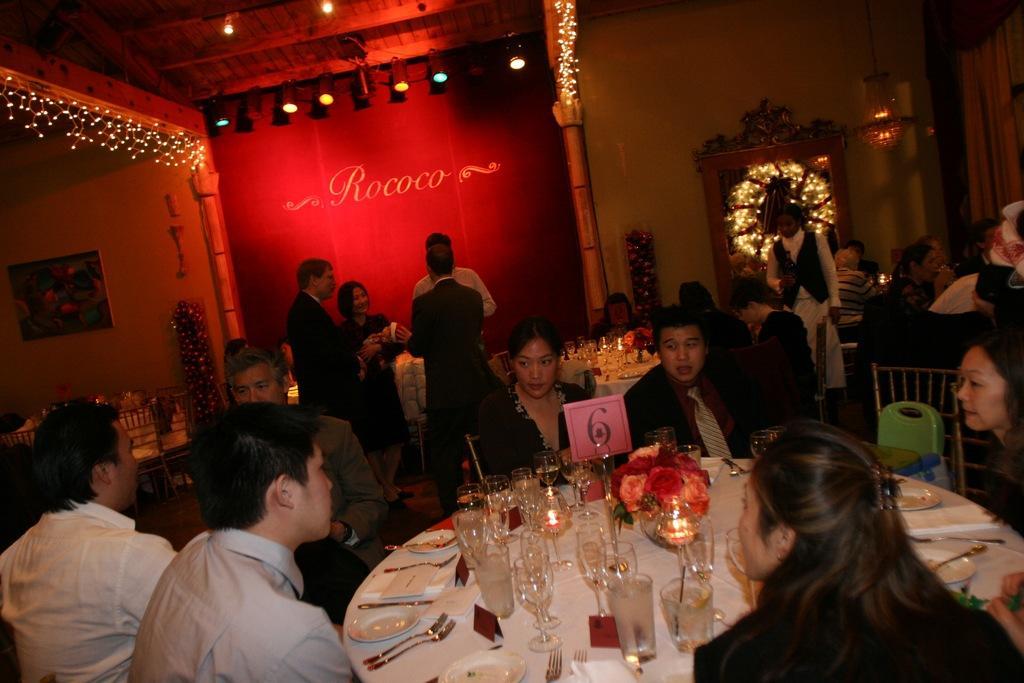In one or two sentences, can you explain what this image depicts? In this picture I can see a few people sitting on the chairs. I can see wine glasses, plates, spoons on the table. I can see a few people standing. I can see decorative lights. 